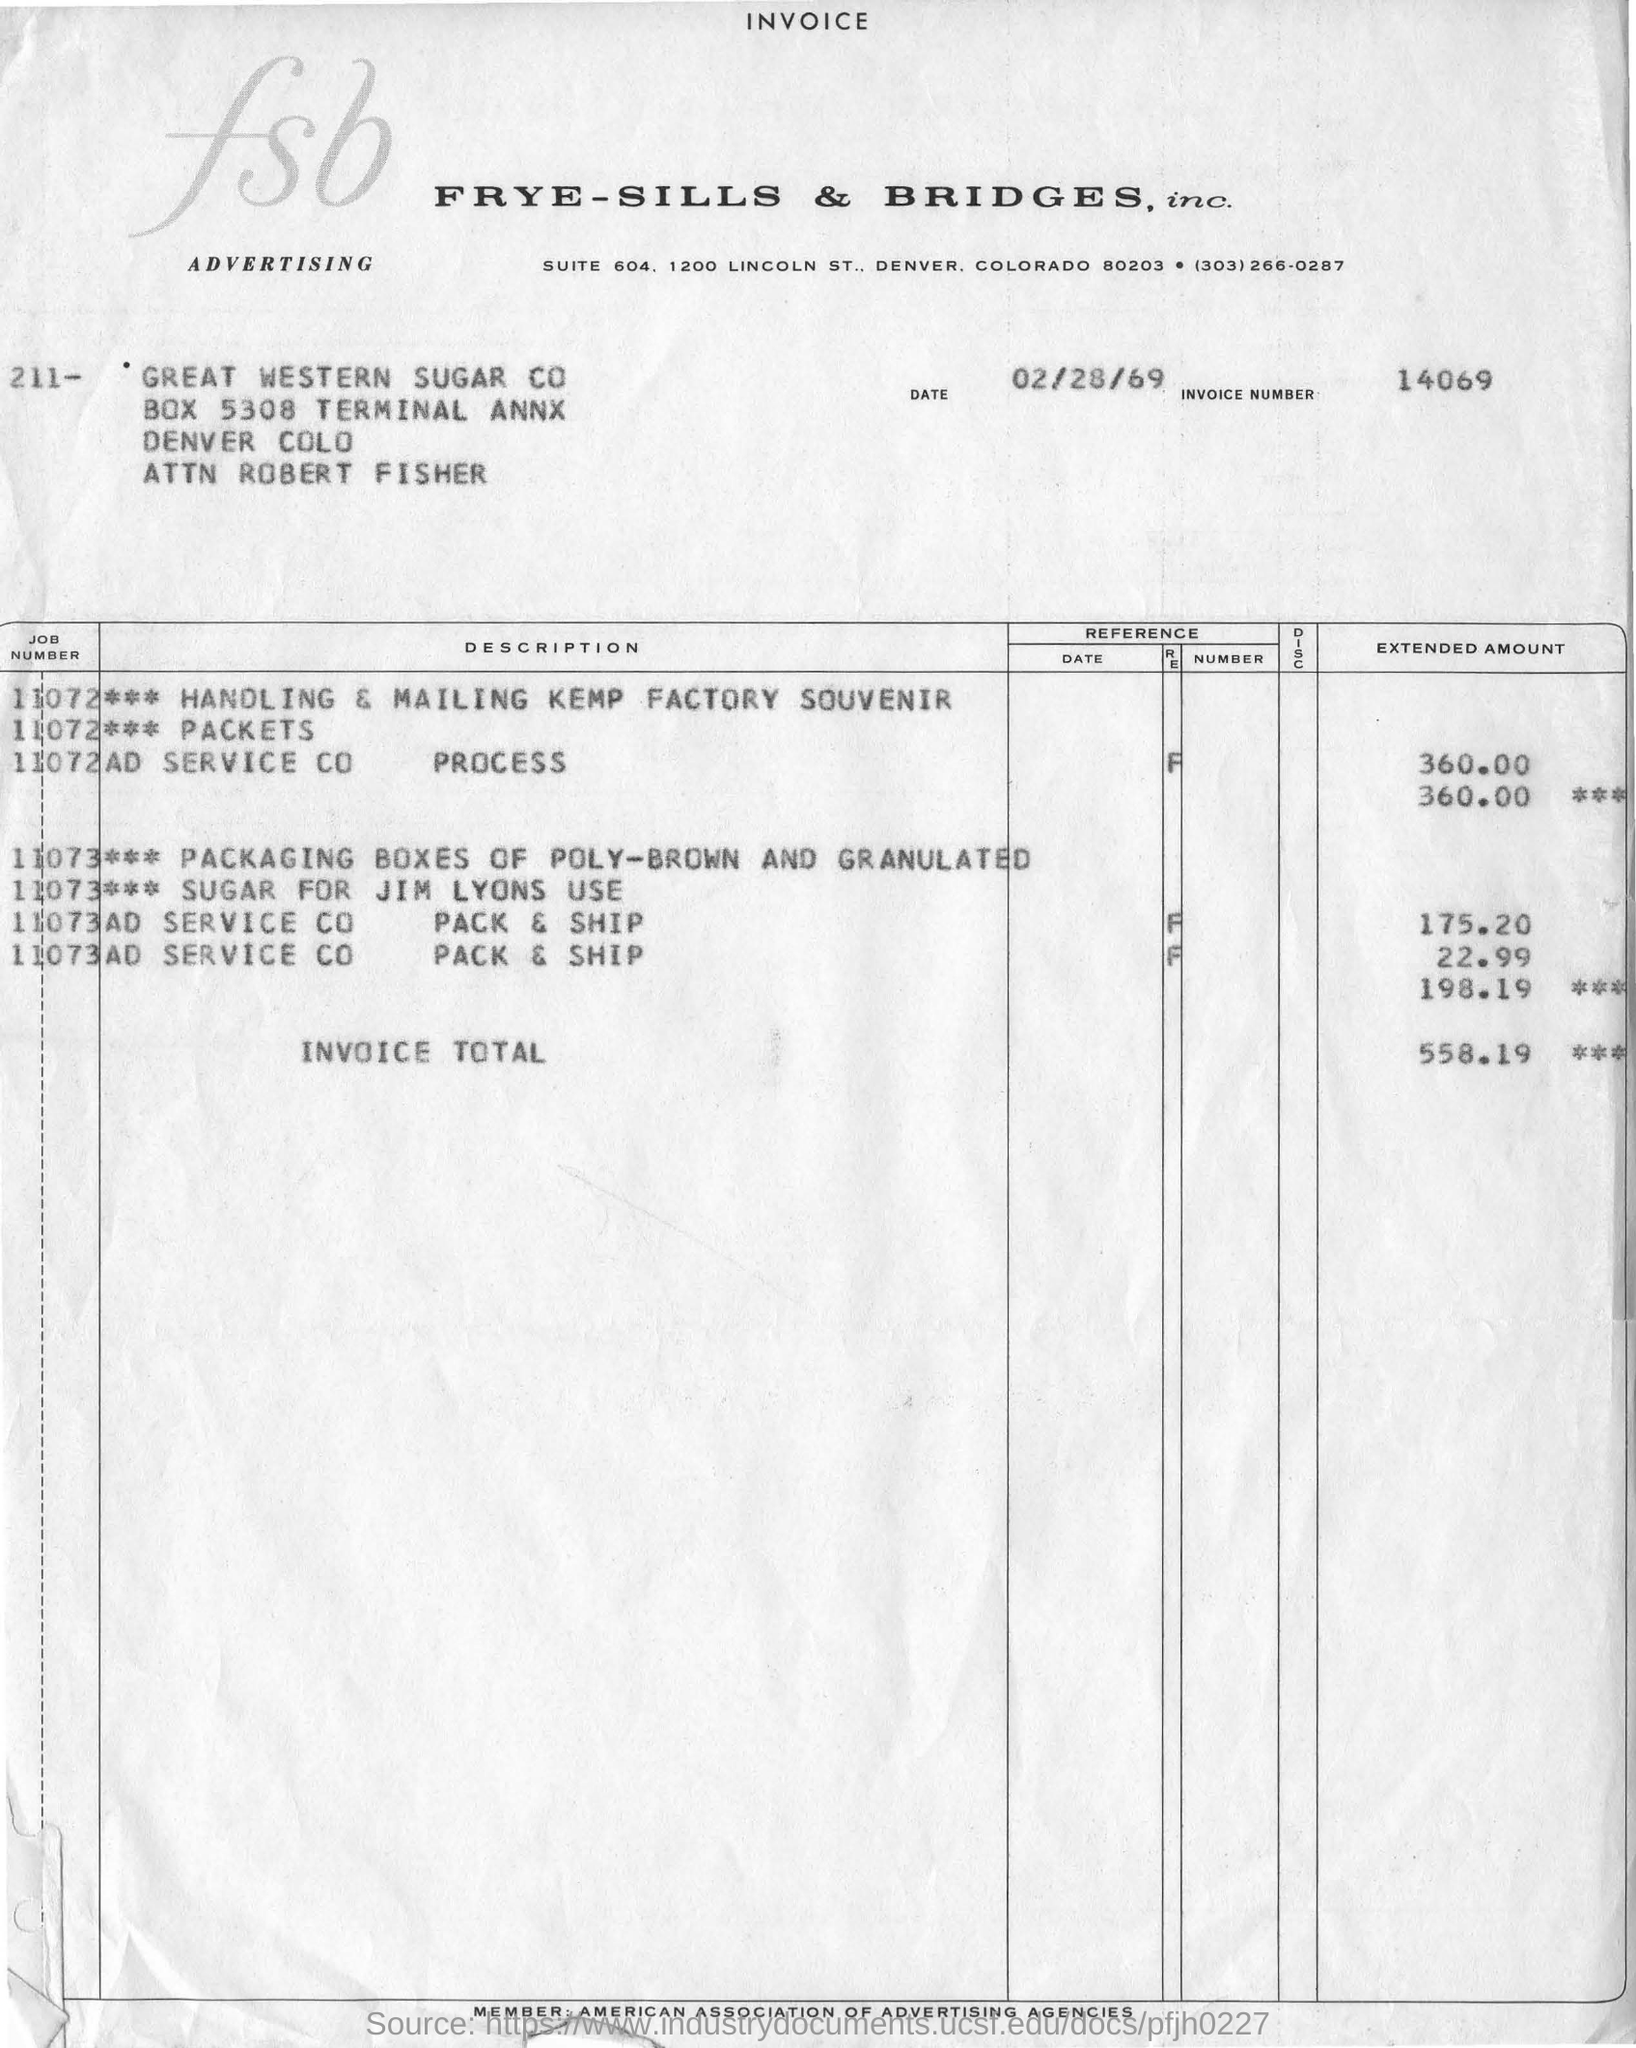Give some essential details in this illustration. The invoice number is 14069. The invoice total is 558.19... This invoice belongs to FRYE-SILLS & BRIDGES, INC. 